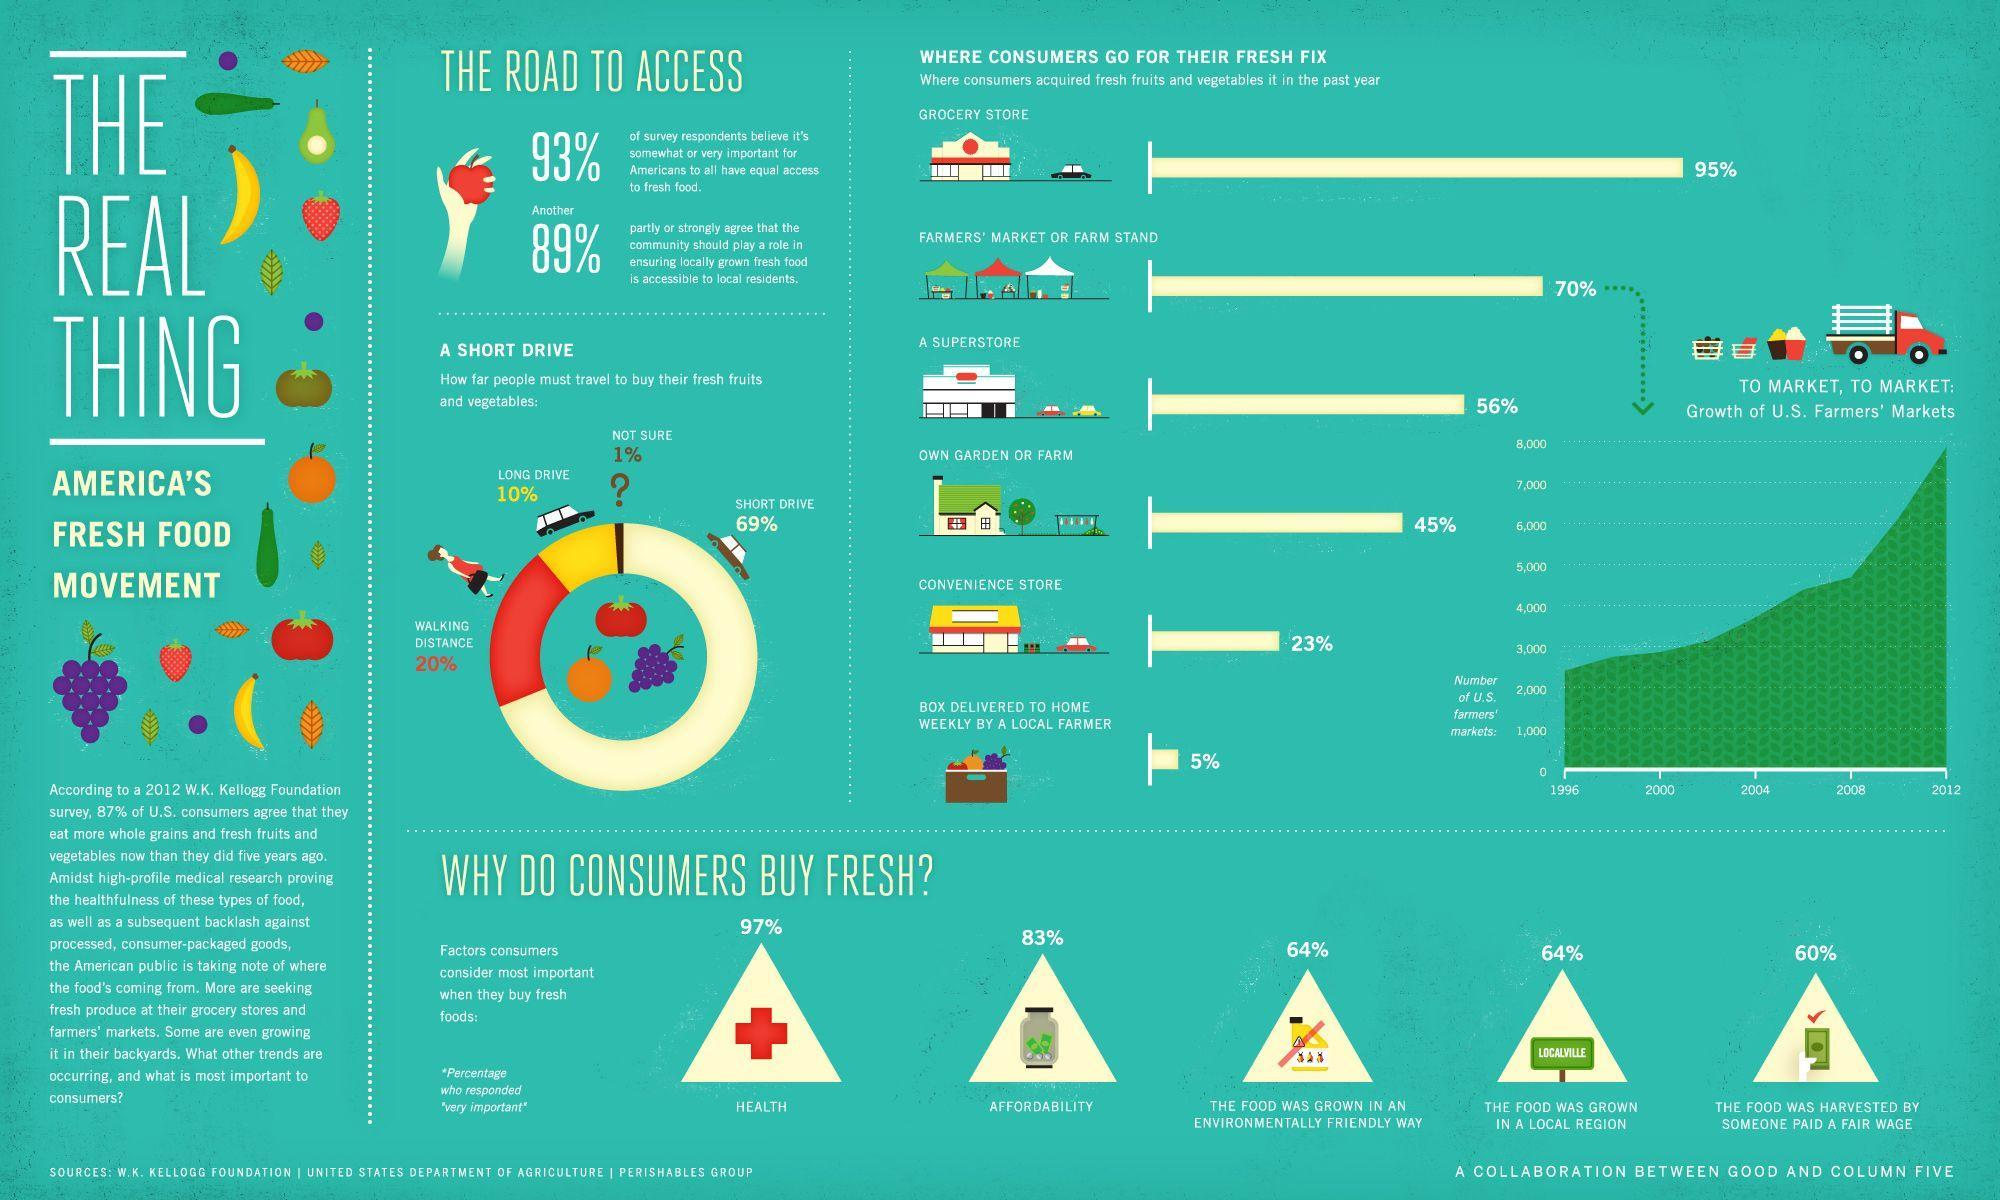What percentage of Americans are planting fruits and vegetables in their home?
Answer the question with a short phrase. 45% What percentage of Americans do not believe that community must do something to ensure fresh food to all? 11 Which place has the second least percentage from where consumers are buying fresh fruits and veggies? CONVENIENCE STORE Which is the factor with second highest percentage while buying fresh food? AFFORDABILITY Which is the second largest place from which consumers can get their fresh fruits and veggies? Farmers' market or Farm stand What percentage of Americans do not believe that its not important for them to have right for fresh food? 7 